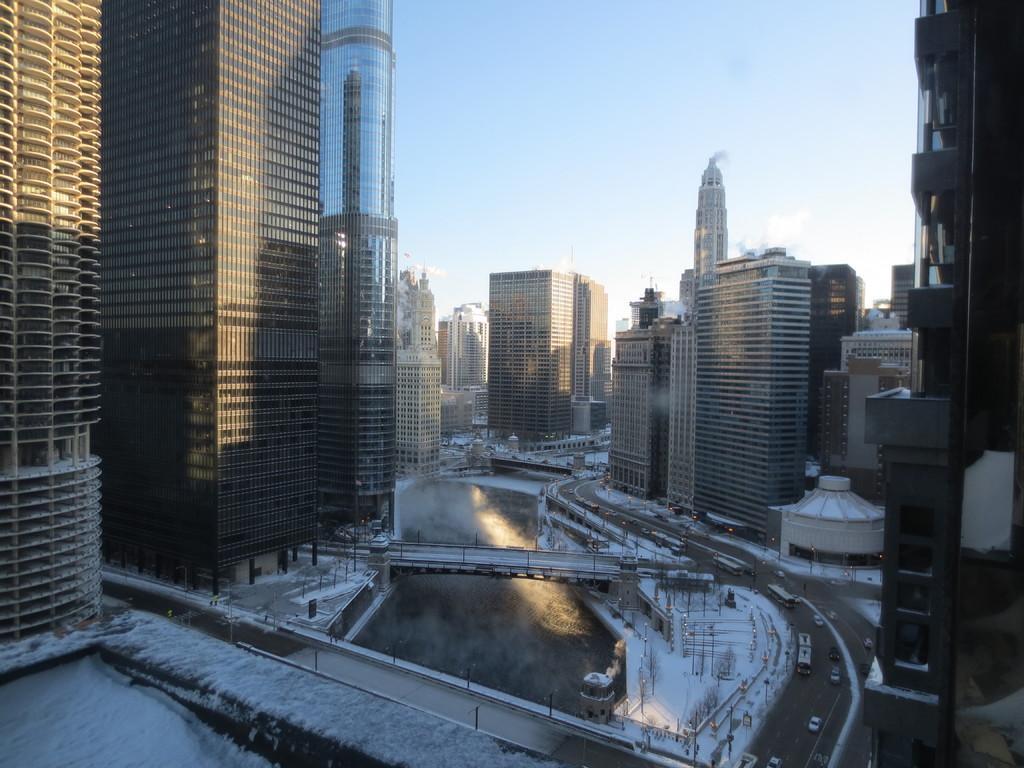In one or two sentences, can you explain what this image depicts? In this image there are buildings. At the bottom there is a canal and a bridge. We can see snow. In the background there is sky. On the right there is a road and we can see vehicles on the road. 